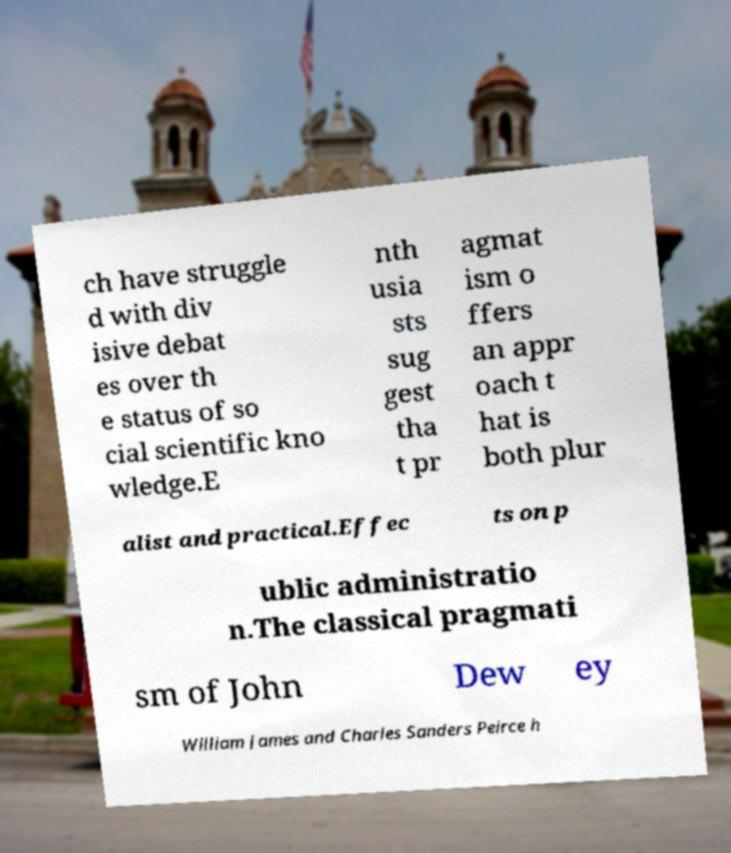There's text embedded in this image that I need extracted. Can you transcribe it verbatim? ch have struggle d with div isive debat es over th e status of so cial scientific kno wledge.E nth usia sts sug gest tha t pr agmat ism o ffers an appr oach t hat is both plur alist and practical.Effec ts on p ublic administratio n.The classical pragmati sm of John Dew ey William James and Charles Sanders Peirce h 